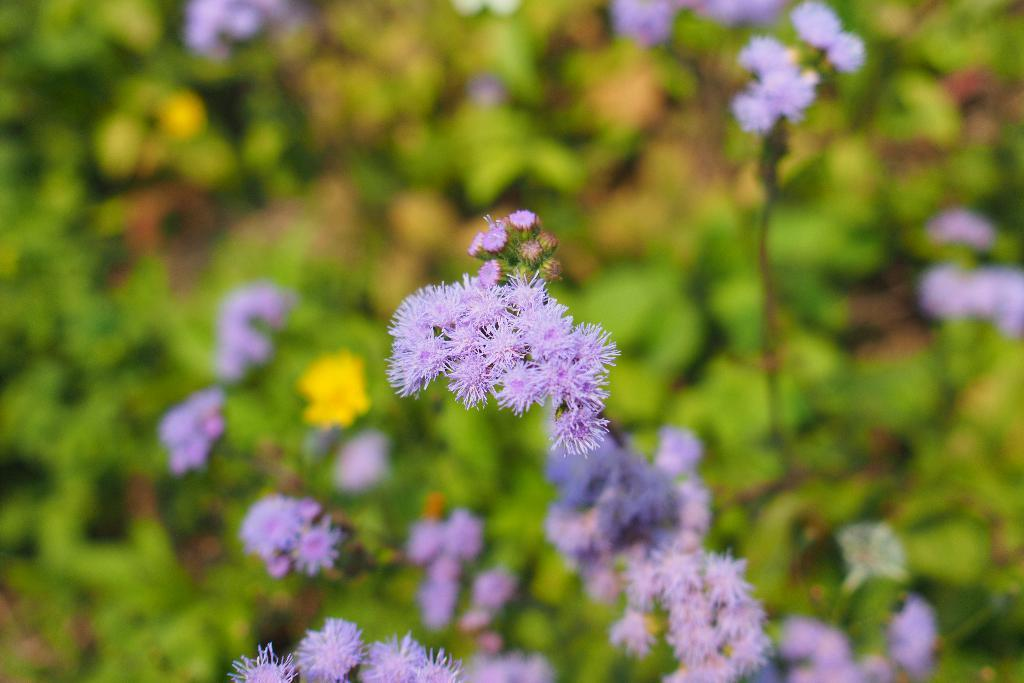What color are the flowers in the middle of the image? The flowers in the middle of the image are lavender color. What can be seen in the background of the image? There are small plants in the background of the image. What type of flame can be seen burning in the image? There is no flame present in the image; it features flowers and small plants. Who is the manager of the plants in the image? The image does not depict a manager or any human presence, only plants and flowers. 